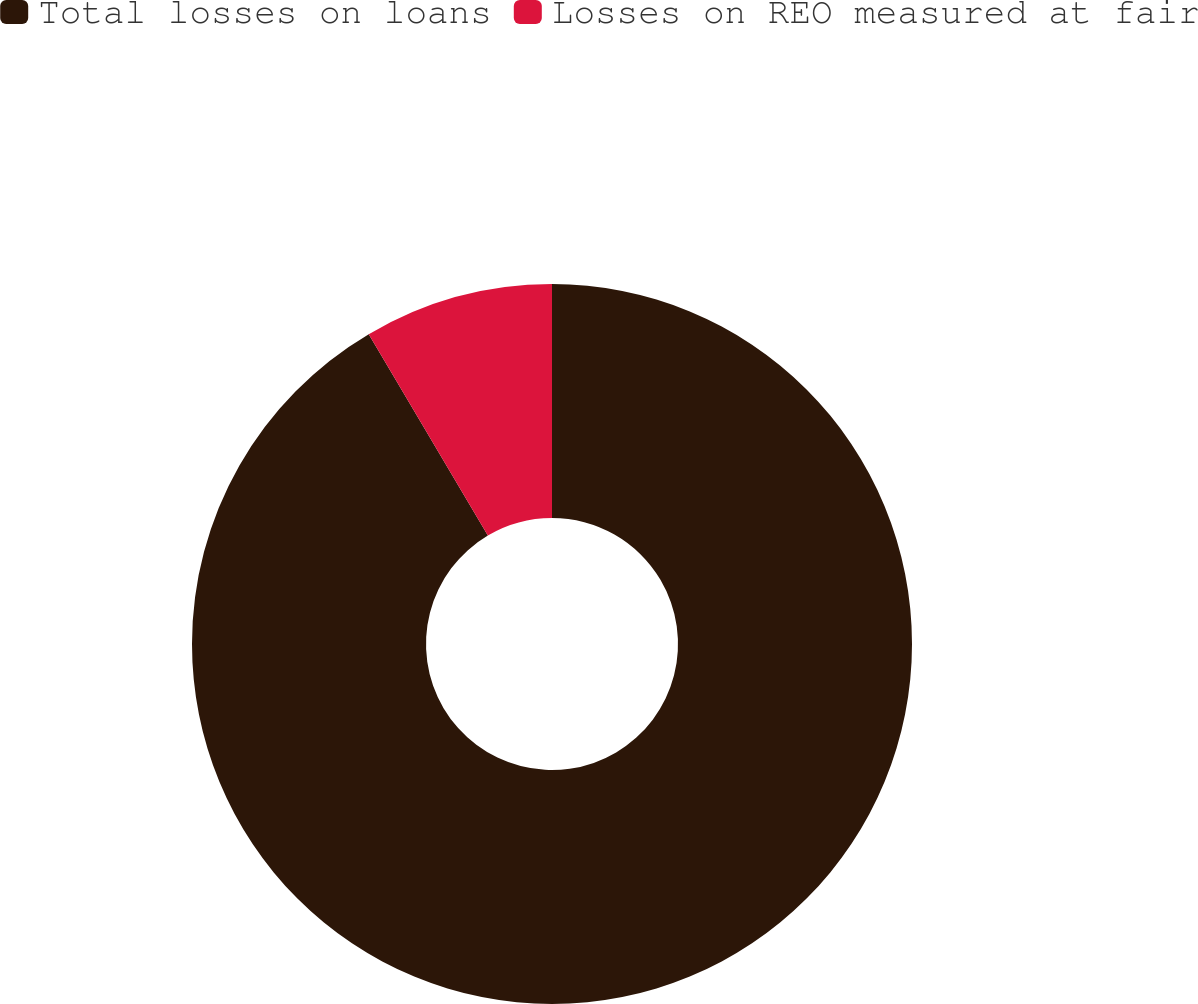Convert chart to OTSL. <chart><loc_0><loc_0><loc_500><loc_500><pie_chart><fcel>Total losses on loans<fcel>Losses on REO measured at fair<nl><fcel>91.5%<fcel>8.5%<nl></chart> 